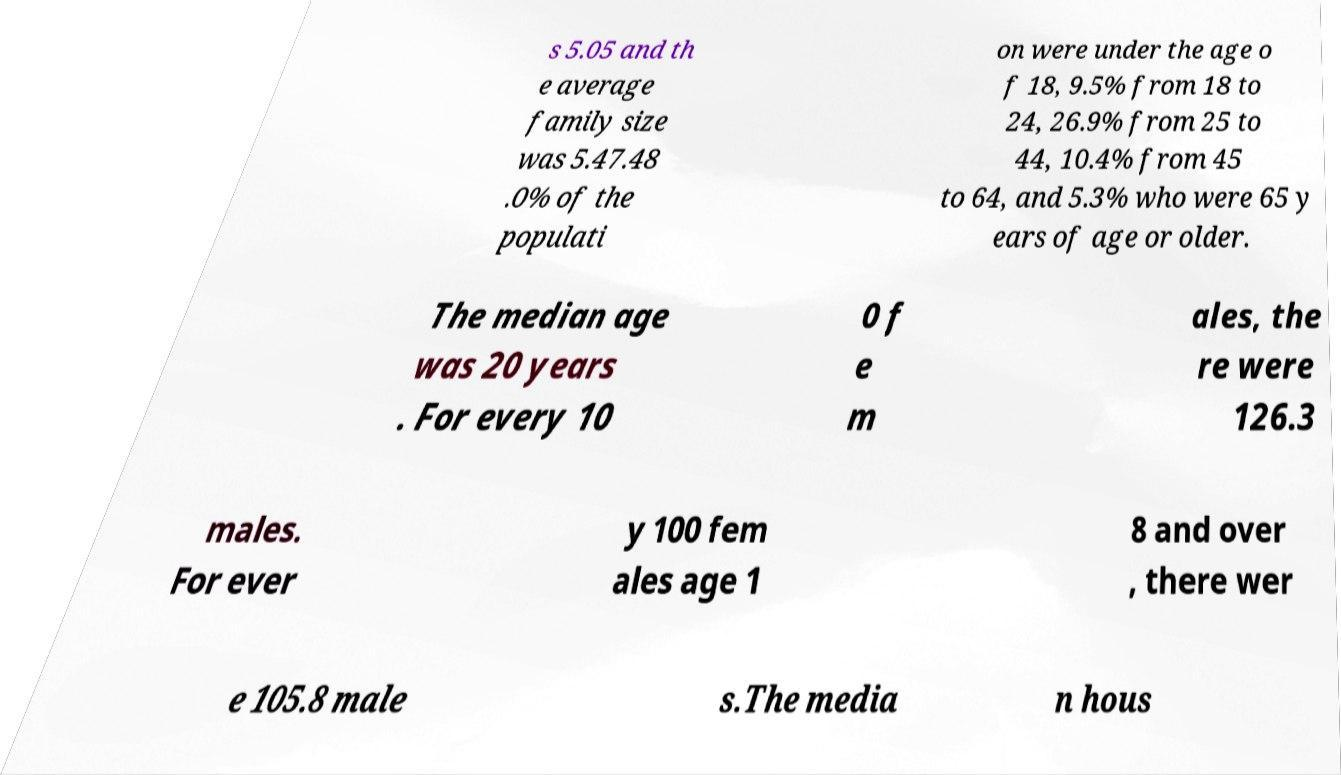What messages or text are displayed in this image? I need them in a readable, typed format. s 5.05 and th e average family size was 5.47.48 .0% of the populati on were under the age o f 18, 9.5% from 18 to 24, 26.9% from 25 to 44, 10.4% from 45 to 64, and 5.3% who were 65 y ears of age or older. The median age was 20 years . For every 10 0 f e m ales, the re were 126.3 males. For ever y 100 fem ales age 1 8 and over , there wer e 105.8 male s.The media n hous 